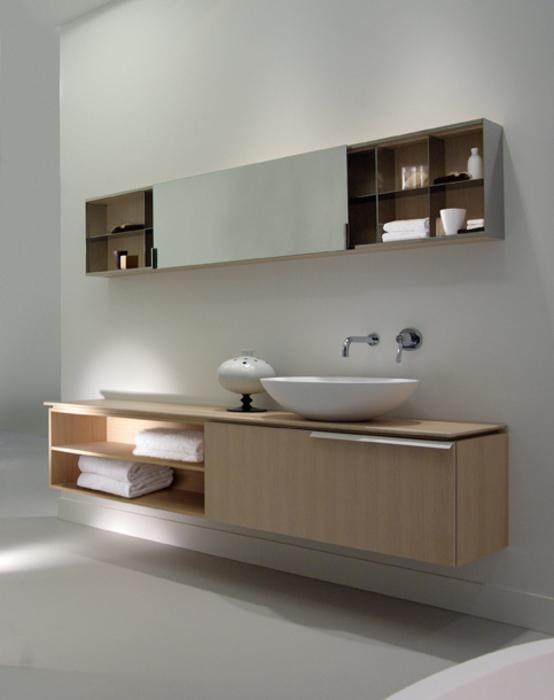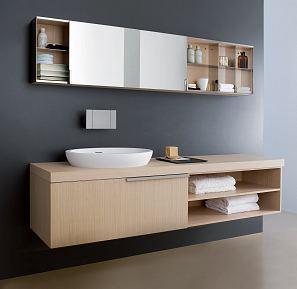The first image is the image on the left, the second image is the image on the right. Examine the images to the left and right. Is the description "There are two basins on the counter in the image on the right." accurate? Answer yes or no. No. The first image is the image on the left, the second image is the image on the right. Given the left and right images, does the statement "There are four white folded towels in a shelf under a sink." hold true? Answer yes or no. Yes. 